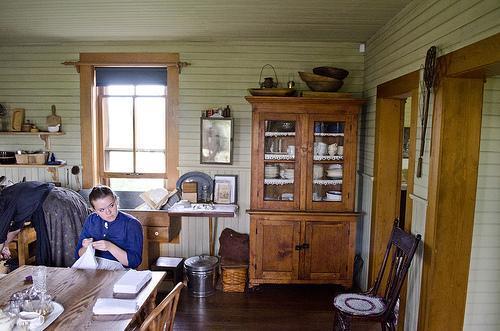How many people are in the room?
Give a very brief answer. 1. 